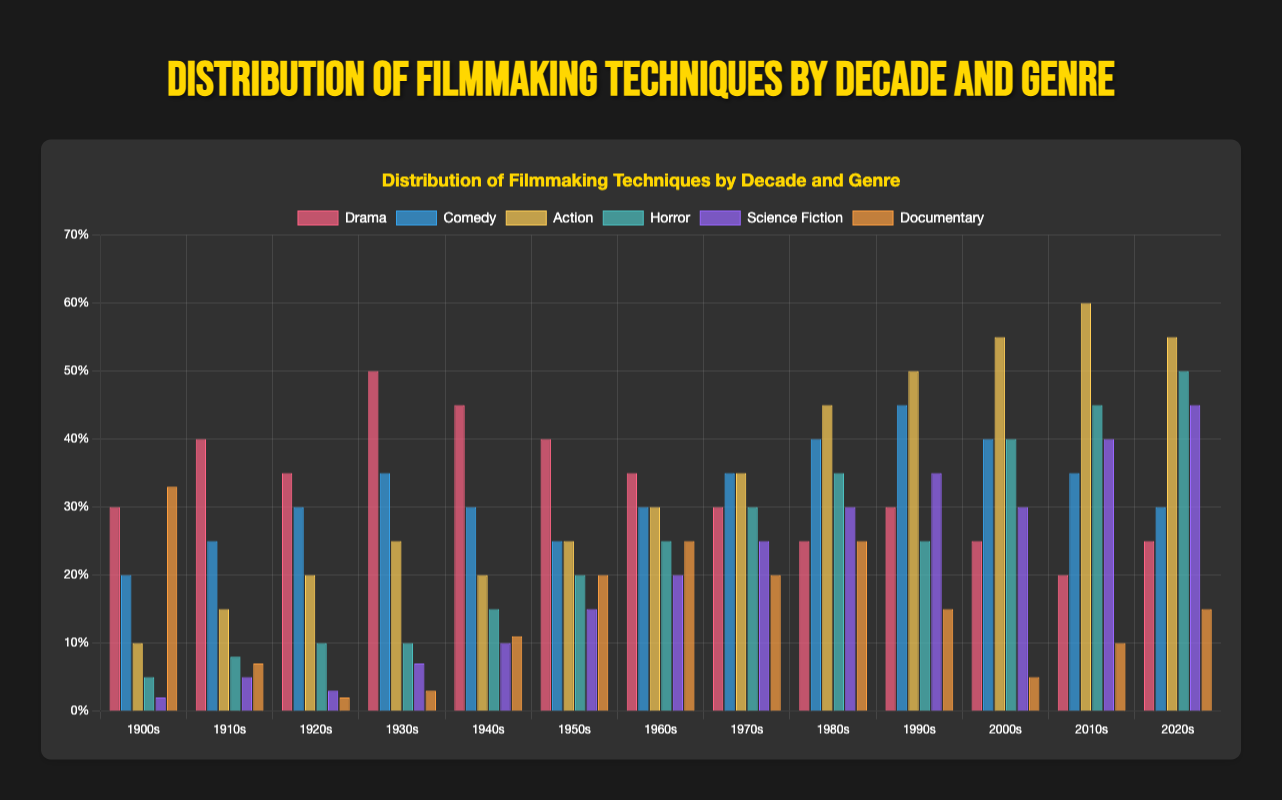Which genre saw the most significant increase in percentage from the 1900s to the 2020s? To determine the genre with the most significant increase, we need to compare the percentage values of each genre from the 1900s and the 2020s, then calculate the difference for each and look for the genre with the highest increase. The largest difference is observed in the Action genre, increasing from 10% in the 1900s to 55% in the 2020s.
Answer: Action Which decade experienced the highest percentage of Documentary films? To find this, we simply look across the bar heights for the Documentary genre for each decade. The highest percentage is in the 1900s, with a value of 33%.
Answer: 1900s What is the sum of the percentages of Drama and Comedy films in the 1930s? Adding the percentages of Drama and Comedy in the 1930s, which are 50% and 35% respectively, the total is 50 + 35 = 85%.
Answer: 85% How did the distribution of Science Fiction films change from the 1970s to the 2010s? Observing the values, Science Fiction films increased from 25% in the 1970s to 40% in the 2010s. This indicates a growing prominence of the Science Fiction genre over the decades.
Answer: Increased by 15% In which decade did Horror films surpass a 30% distribution for the first time? Evaluating the data for the Horror genre across the decades, the first instance of the percentage surpassing 30% is in the 1970s with 30%. However, it surpasses 30% for the first time in the 1980s with 35%.
Answer: 1980s Comparing the 1920s and the 1990s, which genres switched places in their distribution percentages? By comparing the percentages for each genre in the 1920s and the 1990s, we see that Comedy and Action are the genres with notable changes. Comedy rose from 30% to 45%, while Action increased from 20% to 50%. This indicates a switch in prominence between these two genres.
Answer: Comedy and Action What is the average percentage of Action films over the entire given period? The percentages of Action films across the decades are: 10, 15, 20, 25, 20, 25, 30, 35, 45, 50, 55, 60, 55. Summing these values gives a total of 445. There are 13 decades, so the average is 445 / 13 ≈ 34.2%.
Answer: 34.2% Which genre consistently maintained a higher percentage than Horror films from the 1900s to the 2000s? Observing the percentages of genres in each decade, Drama consistently has a higher percentage than Horror from the 1900s to the 2000s.
Answer: Drama Which decade had the least variation in genre distributions? To determine the decade with the least variation, we compare the range (the difference between the highest and lowest values) of the distribution percentages within each decade. The 1920s have values from 2% to 35%, giving a range of 33%. This is the smallest range observed.
Answer: 1920s 